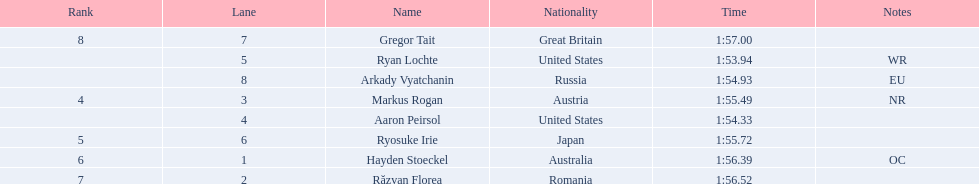What is the name of the contestant in lane 6? Ryosuke Irie. How long did it take that player to complete the race? 1:55.72. 